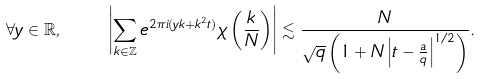Convert formula to latex. <formula><loc_0><loc_0><loc_500><loc_500>\forall y \in \mathbb { R } , \quad \left | \sum _ { k \in \mathbb { Z } } e ^ { 2 \pi i ( y k + k ^ { 2 } t ) } \chi \left ( \frac { k } { N } \right ) \right | \lesssim \frac { N } { \sqrt { q } \left ( 1 + N \left | t - \frac { a } { q } \right | ^ { 1 / 2 } \right ) } .</formula> 